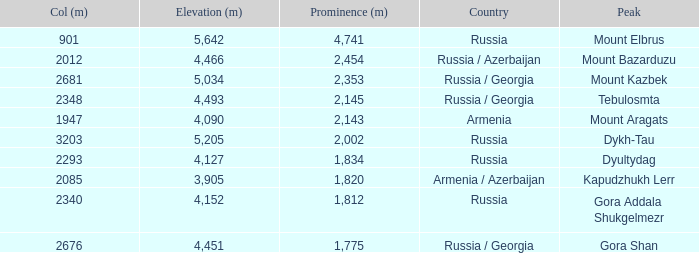With a Col (m) larger than 2012, what is Mount Kazbek's Prominence (m)? 2353.0. 